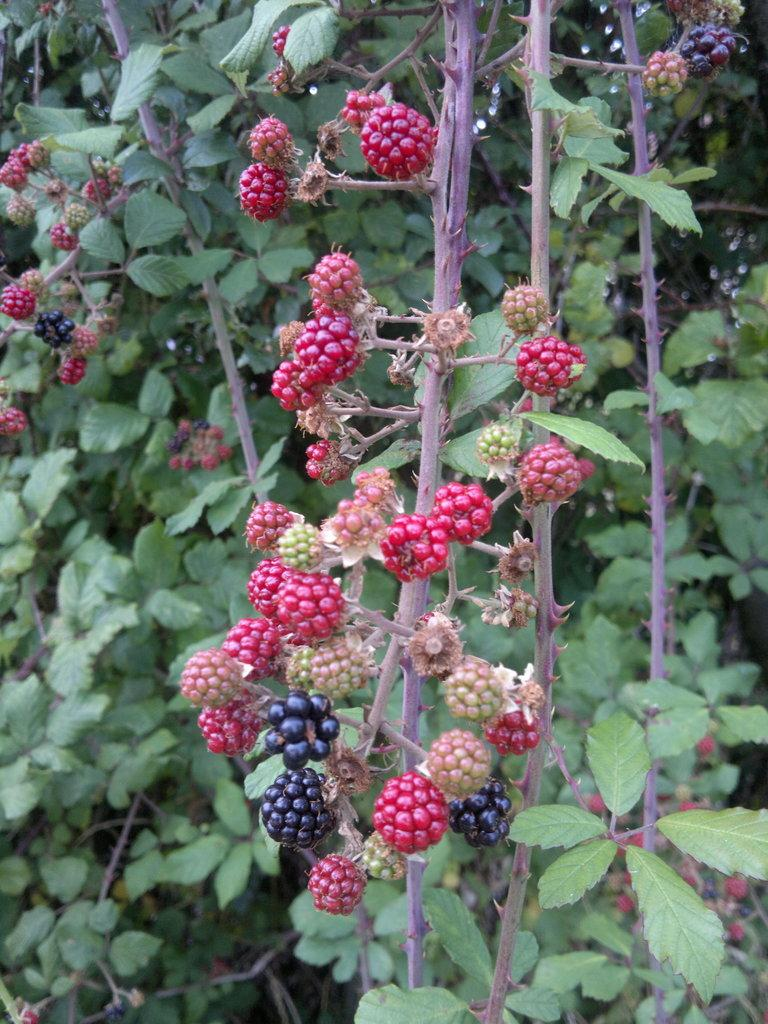What type of vegetation can be seen on the trees in the image? There are fruits on the trees in the image. What type of fruit is the judge holding in the image? There is no judge or fruit held by a judge present in the image; it only features fruits on the trees. 